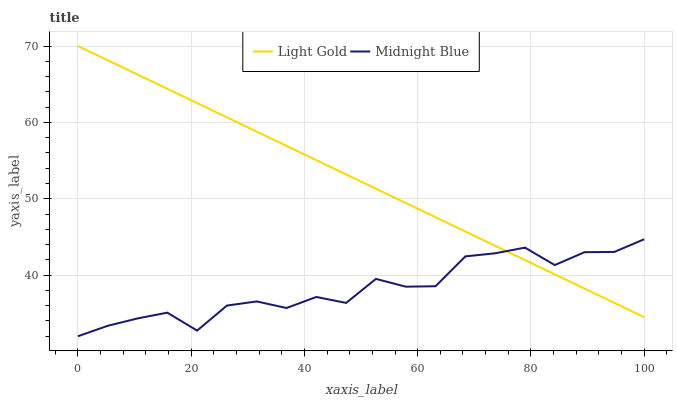Does Midnight Blue have the minimum area under the curve?
Answer yes or no. Yes. Does Light Gold have the maximum area under the curve?
Answer yes or no. Yes. Does Midnight Blue have the maximum area under the curve?
Answer yes or no. No. Is Light Gold the smoothest?
Answer yes or no. Yes. Is Midnight Blue the roughest?
Answer yes or no. Yes. Is Midnight Blue the smoothest?
Answer yes or no. No. Does Midnight Blue have the lowest value?
Answer yes or no. Yes. Does Light Gold have the highest value?
Answer yes or no. Yes. Does Midnight Blue have the highest value?
Answer yes or no. No. Does Light Gold intersect Midnight Blue?
Answer yes or no. Yes. Is Light Gold less than Midnight Blue?
Answer yes or no. No. Is Light Gold greater than Midnight Blue?
Answer yes or no. No. 